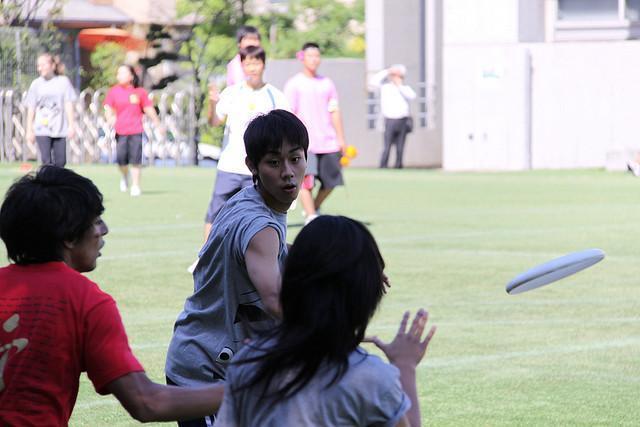How many people are visible?
Give a very brief answer. 8. How many buses are parked?
Give a very brief answer. 0. 